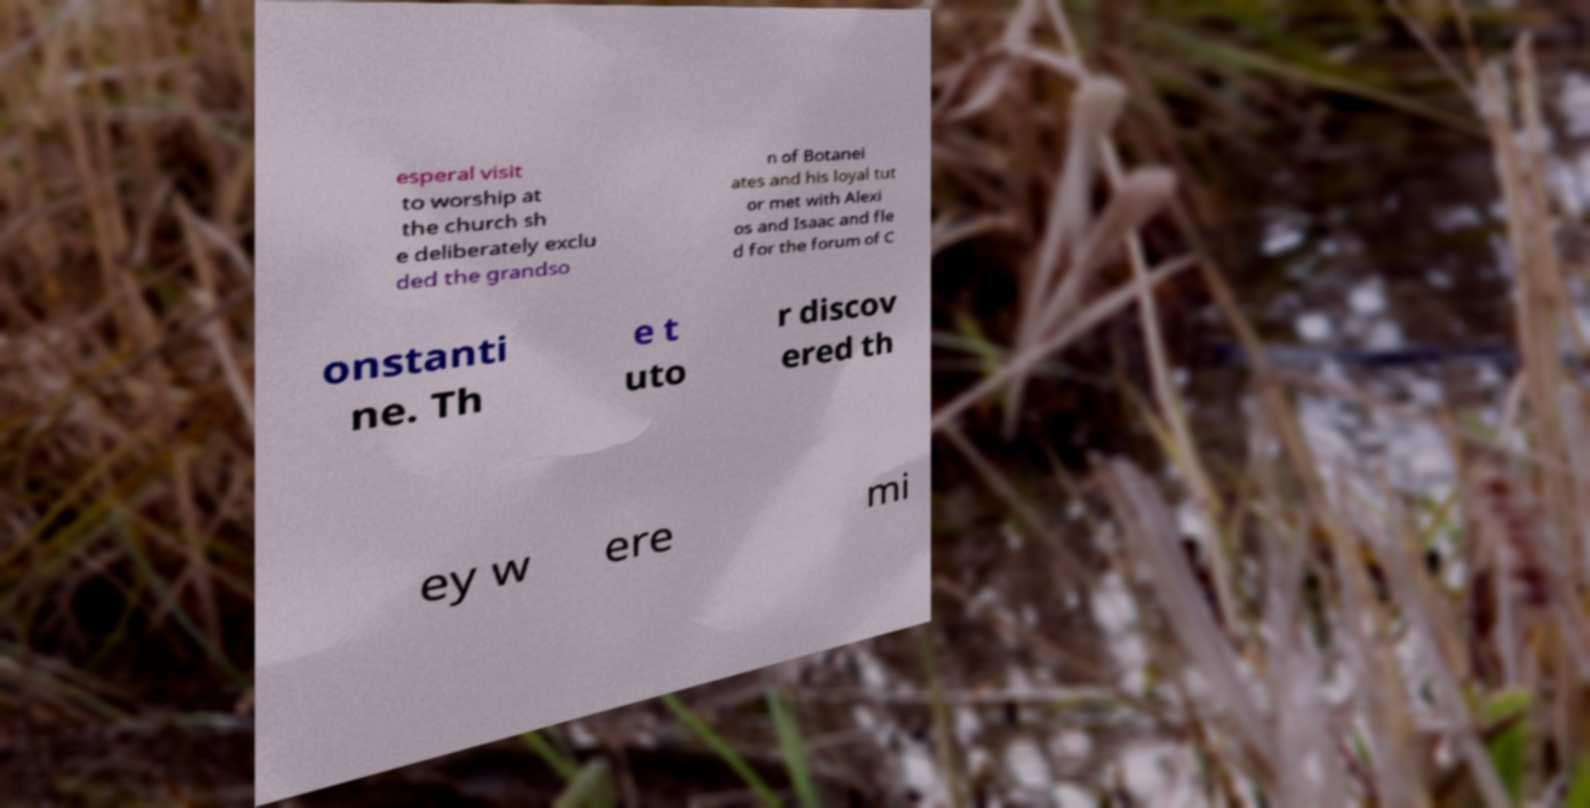Could you assist in decoding the text presented in this image and type it out clearly? esperal visit to worship at the church sh e deliberately exclu ded the grandso n of Botanei ates and his loyal tut or met with Alexi os and Isaac and fle d for the forum of C onstanti ne. Th e t uto r discov ered th ey w ere mi 